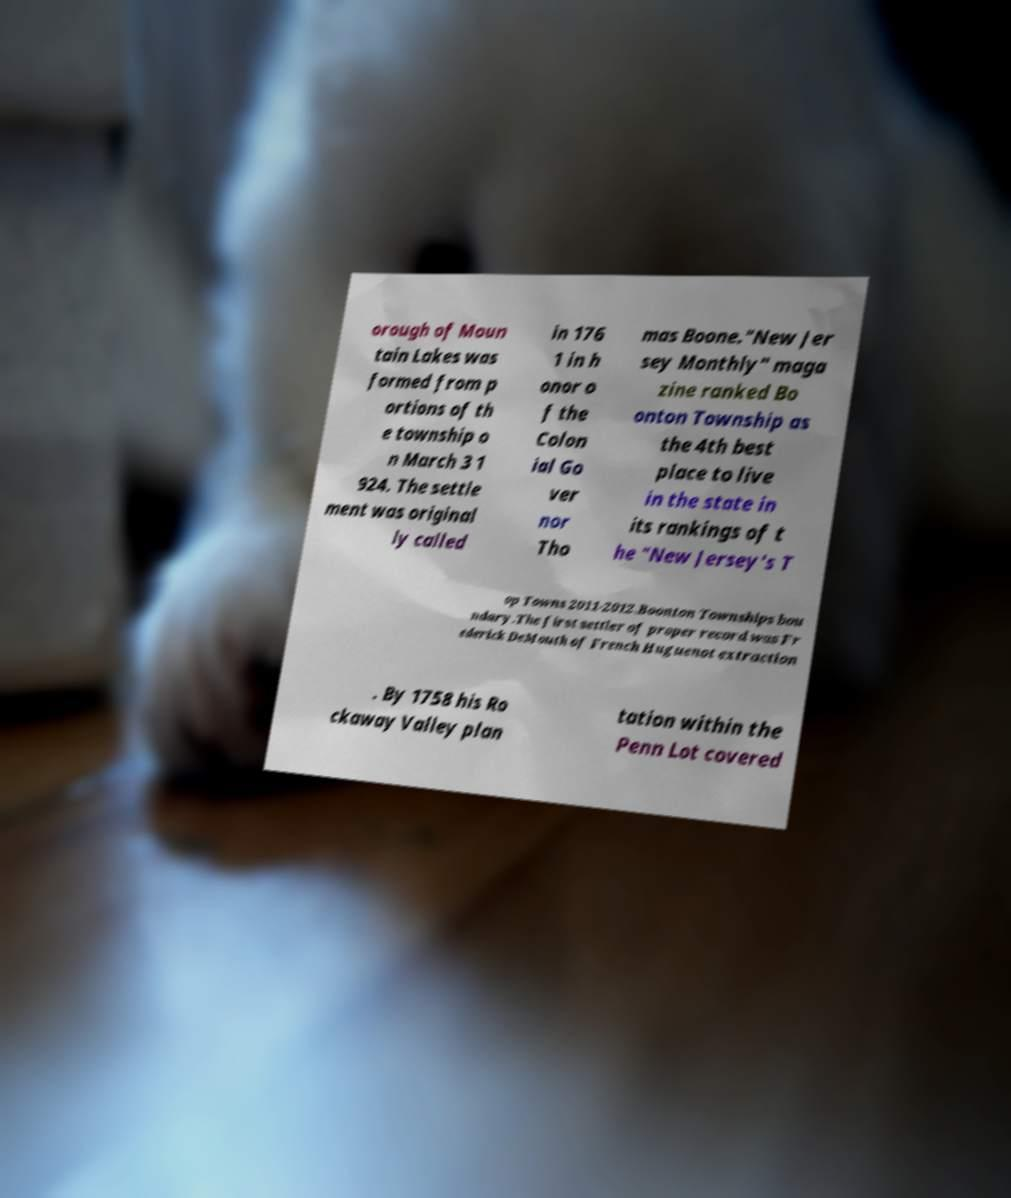Can you accurately transcribe the text from the provided image for me? orough of Moun tain Lakes was formed from p ortions of th e township o n March 3 1 924. The settle ment was original ly called in 176 1 in h onor o f the Colon ial Go ver nor Tho mas Boone."New Jer sey Monthly" maga zine ranked Bo onton Township as the 4th best place to live in the state in its rankings of t he "New Jersey's T op Towns 2011-2012.Boonton Townships bou ndary.The first settler of proper record was Fr ederick DeMouth of French Huguenot extraction . By 1758 his Ro ckaway Valley plan tation within the Penn Lot covered 